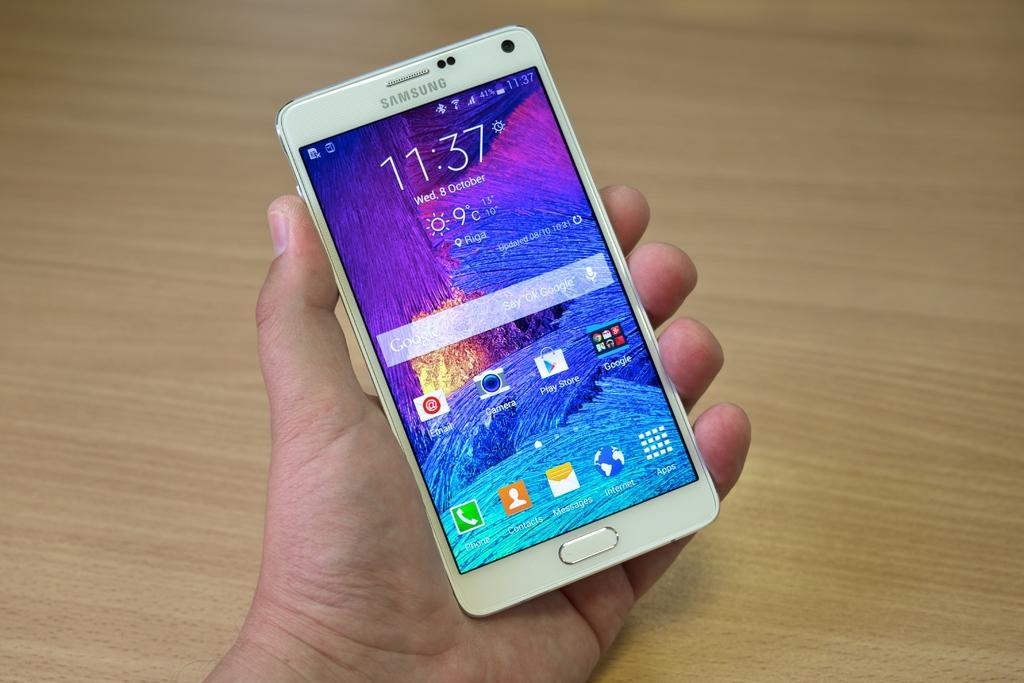<image>
Share a concise interpretation of the image provided. A person is holding a white Samsung phone with the time 11:37 on the screen. 